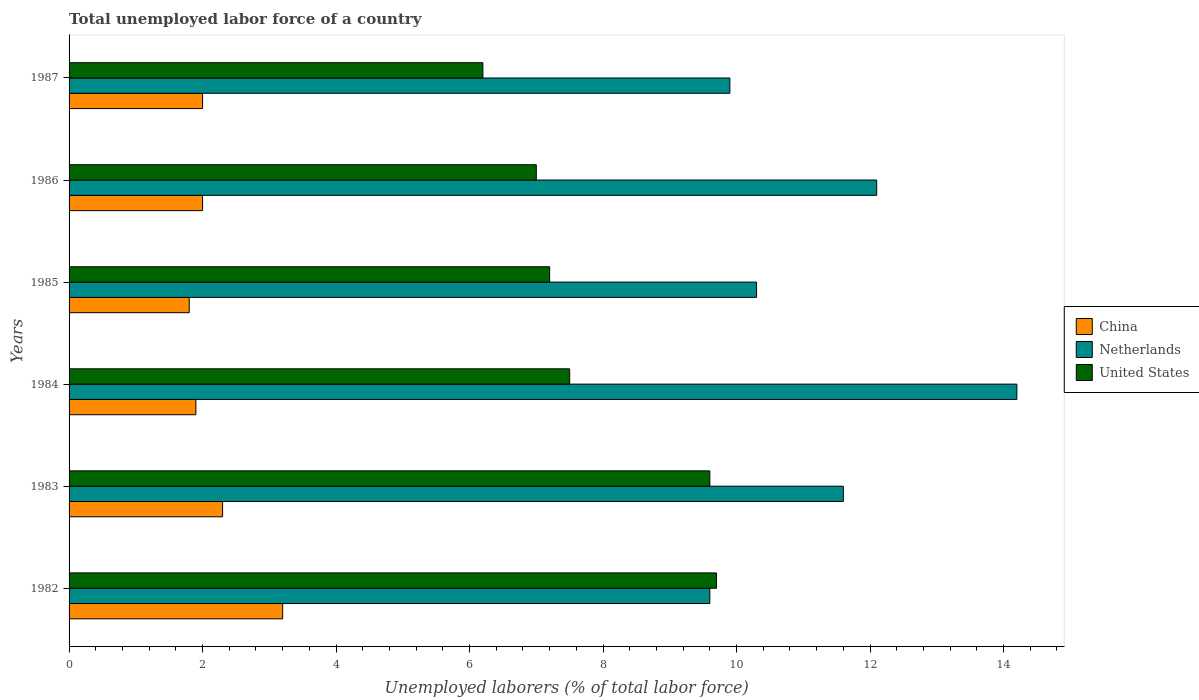How many bars are there on the 6th tick from the top?
Keep it short and to the point. 3. In how many cases, is the number of bars for a given year not equal to the number of legend labels?
Your answer should be very brief. 0. What is the total unemployed labor force in Netherlands in 1985?
Give a very brief answer. 10.3. Across all years, what is the maximum total unemployed labor force in United States?
Make the answer very short. 9.7. Across all years, what is the minimum total unemployed labor force in United States?
Provide a succinct answer. 6.2. In which year was the total unemployed labor force in United States maximum?
Provide a short and direct response. 1982. In which year was the total unemployed labor force in China minimum?
Your response must be concise. 1985. What is the total total unemployed labor force in China in the graph?
Provide a short and direct response. 13.2. What is the difference between the total unemployed labor force in Netherlands in 1984 and that in 1987?
Provide a succinct answer. 4.3. What is the difference between the total unemployed labor force in United States in 1985 and the total unemployed labor force in China in 1982?
Your answer should be very brief. 4. What is the average total unemployed labor force in Netherlands per year?
Keep it short and to the point. 11.28. In the year 1982, what is the difference between the total unemployed labor force in China and total unemployed labor force in Netherlands?
Offer a very short reply. -6.4. What is the ratio of the total unemployed labor force in United States in 1983 to that in 1987?
Your answer should be compact. 1.55. Is the difference between the total unemployed labor force in China in 1985 and 1987 greater than the difference between the total unemployed labor force in Netherlands in 1985 and 1987?
Provide a succinct answer. No. What is the difference between the highest and the second highest total unemployed labor force in China?
Give a very brief answer. 0.9. What is the difference between the highest and the lowest total unemployed labor force in Netherlands?
Give a very brief answer. 4.6. In how many years, is the total unemployed labor force in Netherlands greater than the average total unemployed labor force in Netherlands taken over all years?
Provide a succinct answer. 3. What does the 3rd bar from the top in 1987 represents?
Keep it short and to the point. China. Is it the case that in every year, the sum of the total unemployed labor force in Netherlands and total unemployed labor force in United States is greater than the total unemployed labor force in China?
Offer a terse response. Yes. How many bars are there?
Provide a short and direct response. 18. Are all the bars in the graph horizontal?
Your answer should be compact. Yes. Does the graph contain any zero values?
Your response must be concise. No. Where does the legend appear in the graph?
Your answer should be very brief. Center right. How are the legend labels stacked?
Your answer should be compact. Vertical. What is the title of the graph?
Your answer should be very brief. Total unemployed labor force of a country. What is the label or title of the X-axis?
Make the answer very short. Unemployed laborers (% of total labor force). What is the Unemployed laborers (% of total labor force) of China in 1982?
Ensure brevity in your answer.  3.2. What is the Unemployed laborers (% of total labor force) of Netherlands in 1982?
Offer a very short reply. 9.6. What is the Unemployed laborers (% of total labor force) in United States in 1982?
Give a very brief answer. 9.7. What is the Unemployed laborers (% of total labor force) in China in 1983?
Give a very brief answer. 2.3. What is the Unemployed laborers (% of total labor force) in Netherlands in 1983?
Give a very brief answer. 11.6. What is the Unemployed laborers (% of total labor force) of United States in 1983?
Offer a terse response. 9.6. What is the Unemployed laborers (% of total labor force) in China in 1984?
Offer a terse response. 1.9. What is the Unemployed laborers (% of total labor force) of Netherlands in 1984?
Your response must be concise. 14.2. What is the Unemployed laborers (% of total labor force) of United States in 1984?
Keep it short and to the point. 7.5. What is the Unemployed laborers (% of total labor force) of China in 1985?
Keep it short and to the point. 1.8. What is the Unemployed laborers (% of total labor force) of Netherlands in 1985?
Keep it short and to the point. 10.3. What is the Unemployed laborers (% of total labor force) in United States in 1985?
Keep it short and to the point. 7.2. What is the Unemployed laborers (% of total labor force) of China in 1986?
Your answer should be compact. 2. What is the Unemployed laborers (% of total labor force) in Netherlands in 1986?
Provide a short and direct response. 12.1. What is the Unemployed laborers (% of total labor force) in United States in 1986?
Your answer should be compact. 7. What is the Unemployed laborers (% of total labor force) of China in 1987?
Offer a terse response. 2. What is the Unemployed laborers (% of total labor force) of Netherlands in 1987?
Keep it short and to the point. 9.9. What is the Unemployed laborers (% of total labor force) in United States in 1987?
Keep it short and to the point. 6.2. Across all years, what is the maximum Unemployed laborers (% of total labor force) of China?
Provide a succinct answer. 3.2. Across all years, what is the maximum Unemployed laborers (% of total labor force) of Netherlands?
Make the answer very short. 14.2. Across all years, what is the maximum Unemployed laborers (% of total labor force) of United States?
Your response must be concise. 9.7. Across all years, what is the minimum Unemployed laborers (% of total labor force) in China?
Give a very brief answer. 1.8. Across all years, what is the minimum Unemployed laborers (% of total labor force) of Netherlands?
Keep it short and to the point. 9.6. Across all years, what is the minimum Unemployed laborers (% of total labor force) in United States?
Make the answer very short. 6.2. What is the total Unemployed laborers (% of total labor force) of China in the graph?
Your answer should be very brief. 13.2. What is the total Unemployed laborers (% of total labor force) in Netherlands in the graph?
Your response must be concise. 67.7. What is the total Unemployed laborers (% of total labor force) of United States in the graph?
Your answer should be very brief. 47.2. What is the difference between the Unemployed laborers (% of total labor force) in Netherlands in 1982 and that in 1983?
Keep it short and to the point. -2. What is the difference between the Unemployed laborers (% of total labor force) in China in 1982 and that in 1984?
Offer a very short reply. 1.3. What is the difference between the Unemployed laborers (% of total labor force) of United States in 1982 and that in 1984?
Ensure brevity in your answer.  2.2. What is the difference between the Unemployed laborers (% of total labor force) in China in 1982 and that in 1985?
Keep it short and to the point. 1.4. What is the difference between the Unemployed laborers (% of total labor force) of Netherlands in 1982 and that in 1985?
Keep it short and to the point. -0.7. What is the difference between the Unemployed laborers (% of total labor force) of United States in 1982 and that in 1985?
Make the answer very short. 2.5. What is the difference between the Unemployed laborers (% of total labor force) of United States in 1982 and that in 1986?
Ensure brevity in your answer.  2.7. What is the difference between the Unemployed laborers (% of total labor force) in China in 1982 and that in 1987?
Your answer should be very brief. 1.2. What is the difference between the Unemployed laborers (% of total labor force) in Netherlands in 1982 and that in 1987?
Your answer should be very brief. -0.3. What is the difference between the Unemployed laborers (% of total labor force) of Netherlands in 1983 and that in 1984?
Make the answer very short. -2.6. What is the difference between the Unemployed laborers (% of total labor force) in United States in 1983 and that in 1984?
Give a very brief answer. 2.1. What is the difference between the Unemployed laborers (% of total labor force) of China in 1983 and that in 1986?
Provide a short and direct response. 0.3. What is the difference between the Unemployed laborers (% of total labor force) in United States in 1983 and that in 1987?
Ensure brevity in your answer.  3.4. What is the difference between the Unemployed laborers (% of total labor force) of Netherlands in 1984 and that in 1985?
Your answer should be very brief. 3.9. What is the difference between the Unemployed laborers (% of total labor force) of United States in 1984 and that in 1985?
Keep it short and to the point. 0.3. What is the difference between the Unemployed laborers (% of total labor force) of Netherlands in 1984 and that in 1986?
Offer a very short reply. 2.1. What is the difference between the Unemployed laborers (% of total labor force) in United States in 1984 and that in 1987?
Keep it short and to the point. 1.3. What is the difference between the Unemployed laborers (% of total labor force) in China in 1985 and that in 1986?
Your answer should be compact. -0.2. What is the difference between the Unemployed laborers (% of total labor force) of Netherlands in 1985 and that in 1986?
Offer a very short reply. -1.8. What is the difference between the Unemployed laborers (% of total labor force) in Netherlands in 1985 and that in 1987?
Your answer should be very brief. 0.4. What is the difference between the Unemployed laborers (% of total labor force) in United States in 1985 and that in 1987?
Give a very brief answer. 1. What is the difference between the Unemployed laborers (% of total labor force) of China in 1986 and that in 1987?
Offer a terse response. 0. What is the difference between the Unemployed laborers (% of total labor force) in Netherlands in 1986 and that in 1987?
Offer a terse response. 2.2. What is the difference between the Unemployed laborers (% of total labor force) in United States in 1986 and that in 1987?
Your answer should be compact. 0.8. What is the difference between the Unemployed laborers (% of total labor force) of China in 1982 and the Unemployed laborers (% of total labor force) of United States in 1983?
Make the answer very short. -6.4. What is the difference between the Unemployed laborers (% of total labor force) in Netherlands in 1982 and the Unemployed laborers (% of total labor force) in United States in 1983?
Provide a succinct answer. 0. What is the difference between the Unemployed laborers (% of total labor force) in China in 1982 and the Unemployed laborers (% of total labor force) in Netherlands in 1984?
Your response must be concise. -11. What is the difference between the Unemployed laborers (% of total labor force) of China in 1982 and the Unemployed laborers (% of total labor force) of Netherlands in 1985?
Give a very brief answer. -7.1. What is the difference between the Unemployed laborers (% of total labor force) of Netherlands in 1982 and the Unemployed laborers (% of total labor force) of United States in 1985?
Make the answer very short. 2.4. What is the difference between the Unemployed laborers (% of total labor force) of China in 1982 and the Unemployed laborers (% of total labor force) of Netherlands in 1986?
Make the answer very short. -8.9. What is the difference between the Unemployed laborers (% of total labor force) of China in 1982 and the Unemployed laborers (% of total labor force) of United States in 1986?
Keep it short and to the point. -3.8. What is the difference between the Unemployed laborers (% of total labor force) in Netherlands in 1982 and the Unemployed laborers (% of total labor force) in United States in 1986?
Keep it short and to the point. 2.6. What is the difference between the Unemployed laborers (% of total labor force) in China in 1982 and the Unemployed laborers (% of total labor force) in Netherlands in 1987?
Your response must be concise. -6.7. What is the difference between the Unemployed laborers (% of total labor force) in China in 1982 and the Unemployed laborers (% of total labor force) in United States in 1987?
Give a very brief answer. -3. What is the difference between the Unemployed laborers (% of total labor force) in China in 1983 and the Unemployed laborers (% of total labor force) in Netherlands in 1984?
Make the answer very short. -11.9. What is the difference between the Unemployed laborers (% of total labor force) in China in 1983 and the Unemployed laborers (% of total labor force) in Netherlands in 1985?
Provide a short and direct response. -8. What is the difference between the Unemployed laborers (% of total labor force) in Netherlands in 1983 and the Unemployed laborers (% of total labor force) in United States in 1985?
Give a very brief answer. 4.4. What is the difference between the Unemployed laborers (% of total labor force) of China in 1983 and the Unemployed laborers (% of total labor force) of Netherlands in 1987?
Keep it short and to the point. -7.6. What is the difference between the Unemployed laborers (% of total labor force) in China in 1984 and the Unemployed laborers (% of total labor force) in Netherlands in 1986?
Keep it short and to the point. -10.2. What is the difference between the Unemployed laborers (% of total labor force) in China in 1984 and the Unemployed laborers (% of total labor force) in United States in 1986?
Make the answer very short. -5.1. What is the difference between the Unemployed laborers (% of total labor force) of Netherlands in 1984 and the Unemployed laborers (% of total labor force) of United States in 1986?
Your response must be concise. 7.2. What is the difference between the Unemployed laborers (% of total labor force) of Netherlands in 1984 and the Unemployed laborers (% of total labor force) of United States in 1987?
Give a very brief answer. 8. What is the difference between the Unemployed laborers (% of total labor force) of China in 1985 and the Unemployed laborers (% of total labor force) of Netherlands in 1986?
Your response must be concise. -10.3. What is the difference between the Unemployed laborers (% of total labor force) of China in 1985 and the Unemployed laborers (% of total labor force) of United States in 1986?
Give a very brief answer. -5.2. What is the difference between the Unemployed laborers (% of total labor force) of Netherlands in 1985 and the Unemployed laborers (% of total labor force) of United States in 1986?
Your answer should be compact. 3.3. What is the difference between the Unemployed laborers (% of total labor force) in China in 1985 and the Unemployed laborers (% of total labor force) in Netherlands in 1987?
Keep it short and to the point. -8.1. What is the difference between the Unemployed laborers (% of total labor force) in Netherlands in 1985 and the Unemployed laborers (% of total labor force) in United States in 1987?
Offer a terse response. 4.1. What is the difference between the Unemployed laborers (% of total labor force) of China in 1986 and the Unemployed laborers (% of total labor force) of Netherlands in 1987?
Provide a succinct answer. -7.9. What is the difference between the Unemployed laborers (% of total labor force) in Netherlands in 1986 and the Unemployed laborers (% of total labor force) in United States in 1987?
Make the answer very short. 5.9. What is the average Unemployed laborers (% of total labor force) of China per year?
Your answer should be very brief. 2.2. What is the average Unemployed laborers (% of total labor force) of Netherlands per year?
Give a very brief answer. 11.28. What is the average Unemployed laborers (% of total labor force) of United States per year?
Provide a short and direct response. 7.87. In the year 1983, what is the difference between the Unemployed laborers (% of total labor force) in China and Unemployed laborers (% of total labor force) in Netherlands?
Make the answer very short. -9.3. In the year 1983, what is the difference between the Unemployed laborers (% of total labor force) of China and Unemployed laborers (% of total labor force) of United States?
Your answer should be compact. -7.3. In the year 1984, what is the difference between the Unemployed laborers (% of total labor force) in China and Unemployed laborers (% of total labor force) in United States?
Your answer should be compact. -5.6. In the year 1985, what is the difference between the Unemployed laborers (% of total labor force) of China and Unemployed laborers (% of total labor force) of United States?
Make the answer very short. -5.4. In the year 1985, what is the difference between the Unemployed laborers (% of total labor force) of Netherlands and Unemployed laborers (% of total labor force) of United States?
Your answer should be very brief. 3.1. In the year 1986, what is the difference between the Unemployed laborers (% of total labor force) in China and Unemployed laborers (% of total labor force) in United States?
Provide a succinct answer. -5. In the year 1986, what is the difference between the Unemployed laborers (% of total labor force) of Netherlands and Unemployed laborers (% of total labor force) of United States?
Your response must be concise. 5.1. In the year 1987, what is the difference between the Unemployed laborers (% of total labor force) in China and Unemployed laborers (% of total labor force) in United States?
Provide a short and direct response. -4.2. What is the ratio of the Unemployed laborers (% of total labor force) in China in 1982 to that in 1983?
Offer a very short reply. 1.39. What is the ratio of the Unemployed laborers (% of total labor force) of Netherlands in 1982 to that in 1983?
Provide a short and direct response. 0.83. What is the ratio of the Unemployed laborers (% of total labor force) of United States in 1982 to that in 1983?
Make the answer very short. 1.01. What is the ratio of the Unemployed laborers (% of total labor force) of China in 1982 to that in 1984?
Provide a short and direct response. 1.68. What is the ratio of the Unemployed laborers (% of total labor force) of Netherlands in 1982 to that in 1984?
Keep it short and to the point. 0.68. What is the ratio of the Unemployed laborers (% of total labor force) in United States in 1982 to that in 1984?
Offer a terse response. 1.29. What is the ratio of the Unemployed laborers (% of total labor force) of China in 1982 to that in 1985?
Offer a terse response. 1.78. What is the ratio of the Unemployed laborers (% of total labor force) in Netherlands in 1982 to that in 1985?
Your response must be concise. 0.93. What is the ratio of the Unemployed laborers (% of total labor force) in United States in 1982 to that in 1985?
Your answer should be very brief. 1.35. What is the ratio of the Unemployed laborers (% of total labor force) of China in 1982 to that in 1986?
Your answer should be very brief. 1.6. What is the ratio of the Unemployed laborers (% of total labor force) in Netherlands in 1982 to that in 1986?
Make the answer very short. 0.79. What is the ratio of the Unemployed laborers (% of total labor force) in United States in 1982 to that in 1986?
Ensure brevity in your answer.  1.39. What is the ratio of the Unemployed laborers (% of total labor force) of China in 1982 to that in 1987?
Your answer should be compact. 1.6. What is the ratio of the Unemployed laborers (% of total labor force) in Netherlands in 1982 to that in 1987?
Keep it short and to the point. 0.97. What is the ratio of the Unemployed laborers (% of total labor force) of United States in 1982 to that in 1987?
Your answer should be compact. 1.56. What is the ratio of the Unemployed laborers (% of total labor force) of China in 1983 to that in 1984?
Keep it short and to the point. 1.21. What is the ratio of the Unemployed laborers (% of total labor force) in Netherlands in 1983 to that in 1984?
Offer a very short reply. 0.82. What is the ratio of the Unemployed laborers (% of total labor force) in United States in 1983 to that in 1984?
Provide a succinct answer. 1.28. What is the ratio of the Unemployed laborers (% of total labor force) in China in 1983 to that in 1985?
Your response must be concise. 1.28. What is the ratio of the Unemployed laborers (% of total labor force) in Netherlands in 1983 to that in 1985?
Offer a terse response. 1.13. What is the ratio of the Unemployed laborers (% of total labor force) in China in 1983 to that in 1986?
Offer a terse response. 1.15. What is the ratio of the Unemployed laborers (% of total labor force) in Netherlands in 1983 to that in 1986?
Your answer should be very brief. 0.96. What is the ratio of the Unemployed laborers (% of total labor force) in United States in 1983 to that in 1986?
Your answer should be compact. 1.37. What is the ratio of the Unemployed laborers (% of total labor force) of China in 1983 to that in 1987?
Your response must be concise. 1.15. What is the ratio of the Unemployed laborers (% of total labor force) of Netherlands in 1983 to that in 1987?
Give a very brief answer. 1.17. What is the ratio of the Unemployed laborers (% of total labor force) of United States in 1983 to that in 1987?
Keep it short and to the point. 1.55. What is the ratio of the Unemployed laborers (% of total labor force) of China in 1984 to that in 1985?
Offer a terse response. 1.06. What is the ratio of the Unemployed laborers (% of total labor force) of Netherlands in 1984 to that in 1985?
Offer a very short reply. 1.38. What is the ratio of the Unemployed laborers (% of total labor force) of United States in 1984 to that in 1985?
Offer a very short reply. 1.04. What is the ratio of the Unemployed laborers (% of total labor force) in Netherlands in 1984 to that in 1986?
Offer a terse response. 1.17. What is the ratio of the Unemployed laborers (% of total labor force) in United States in 1984 to that in 1986?
Make the answer very short. 1.07. What is the ratio of the Unemployed laborers (% of total labor force) in China in 1984 to that in 1987?
Your response must be concise. 0.95. What is the ratio of the Unemployed laborers (% of total labor force) of Netherlands in 1984 to that in 1987?
Provide a succinct answer. 1.43. What is the ratio of the Unemployed laborers (% of total labor force) of United States in 1984 to that in 1987?
Your response must be concise. 1.21. What is the ratio of the Unemployed laborers (% of total labor force) of Netherlands in 1985 to that in 1986?
Provide a succinct answer. 0.85. What is the ratio of the Unemployed laborers (% of total labor force) in United States in 1985 to that in 1986?
Your answer should be very brief. 1.03. What is the ratio of the Unemployed laborers (% of total labor force) in China in 1985 to that in 1987?
Offer a terse response. 0.9. What is the ratio of the Unemployed laborers (% of total labor force) of Netherlands in 1985 to that in 1987?
Keep it short and to the point. 1.04. What is the ratio of the Unemployed laborers (% of total labor force) in United States in 1985 to that in 1987?
Ensure brevity in your answer.  1.16. What is the ratio of the Unemployed laborers (% of total labor force) in China in 1986 to that in 1987?
Give a very brief answer. 1. What is the ratio of the Unemployed laborers (% of total labor force) of Netherlands in 1986 to that in 1987?
Your response must be concise. 1.22. What is the ratio of the Unemployed laborers (% of total labor force) of United States in 1986 to that in 1987?
Ensure brevity in your answer.  1.13. What is the difference between the highest and the second highest Unemployed laborers (% of total labor force) of Netherlands?
Your response must be concise. 2.1. What is the difference between the highest and the second highest Unemployed laborers (% of total labor force) in United States?
Make the answer very short. 0.1. What is the difference between the highest and the lowest Unemployed laborers (% of total labor force) of China?
Your answer should be compact. 1.4. What is the difference between the highest and the lowest Unemployed laborers (% of total labor force) in United States?
Ensure brevity in your answer.  3.5. 